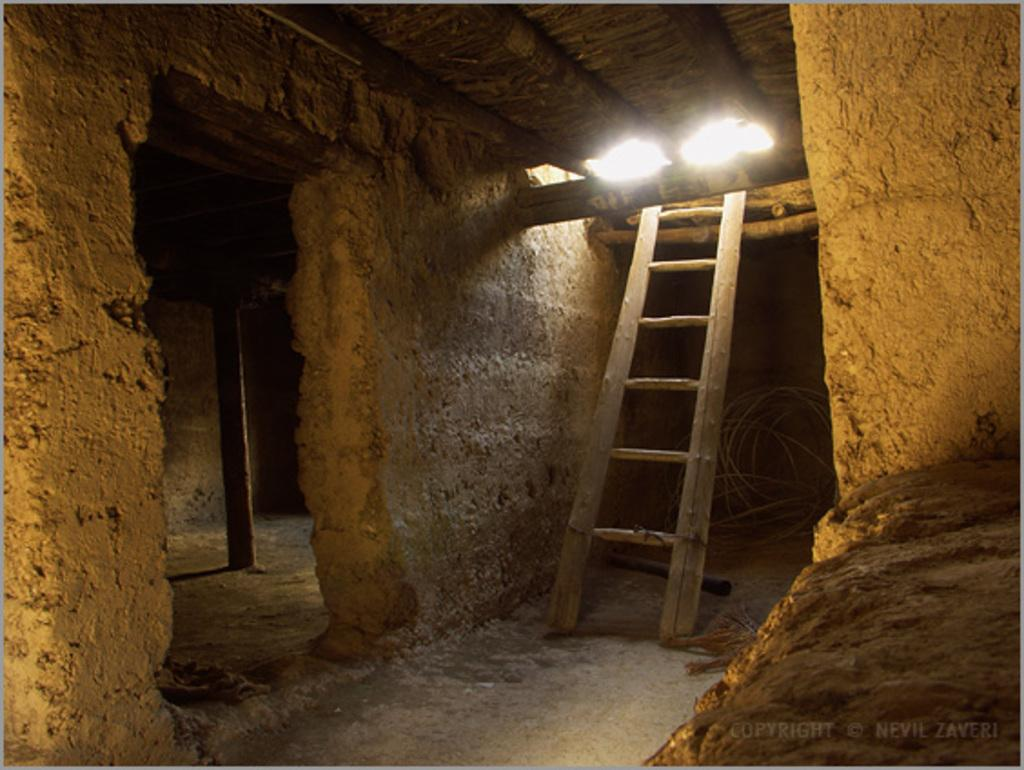What type of location is depicted in the image? The image shows an inner view of a building. What object can be seen in the image that is used for climbing or reaching high places? There is a ladder in the image. What other object is present in the image that is made of wood? There is a wooden pole in the image. What can be seen on the ground in the image? There are wires on the ground in the image. What type of punishment is being administered in the image? There is no indication of punishment in the image; it shows an inner view of a building with a ladder, wooden pole, and wires on the ground. What type of voyage is being depicted in the image? There is no voyage depicted in the image; it shows an inner view of a building with a ladder, wooden pole, and wires on the ground. 